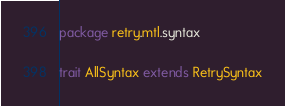<code> <loc_0><loc_0><loc_500><loc_500><_Scala_>package retry.mtl.syntax

trait AllSyntax extends RetrySyntax
</code> 